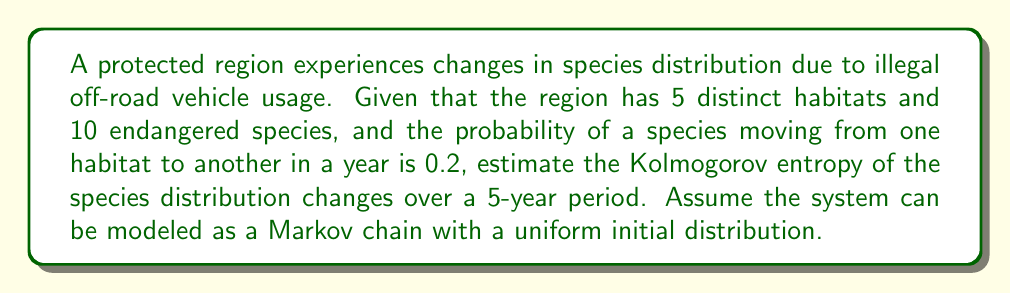Provide a solution to this math problem. To estimate the Kolmogorov entropy of the species distribution changes, we'll follow these steps:

1. Identify the Markov chain transition matrix:
   The probability of staying in the same habitat is $1 - 0.2 = 0.8$, and the probability of moving to any of the other 4 habitats is $0.2 / 4 = 0.05$.

   $$P = \begin{bmatrix}
   0.8 & 0.05 & 0.05 & 0.05 & 0.05 \\
   0.05 & 0.8 & 0.05 & 0.05 & 0.05 \\
   0.05 & 0.05 & 0.8 & 0.05 & 0.05 \\
   0.05 & 0.05 & 0.05 & 0.8 & 0.05 \\
   0.05 & 0.05 & 0.05 & 0.05 & 0.8
   \end{bmatrix}$$

2. Calculate the stationary distribution $\pi$:
   Given the uniform initial distribution, the stationary distribution is also uniform:
   
   $$\pi = (0.2, 0.2, 0.2, 0.2, 0.2)$$

3. Compute the Kolmogorov entropy rate:
   The Kolmogorov entropy rate $h$ is given by:

   $$h = -\sum_{i,j} \pi_i P_{ij} \log P_{ij}$$

   $$h = -5 \cdot (0.2 \cdot 0.8 \log 0.8 + 4 \cdot 0.2 \cdot 0.05 \log 0.05)$$
   $$h \approx 0.5004$$

4. Estimate the Kolmogorov entropy over 5 years:
   The Kolmogorov entropy $H$ over a time period $t$ is approximately:

   $$H \approx h \cdot t$$
   $$H \approx 0.5004 \cdot 5 = 2.502$$

5. Adjust for the number of species:
   Since there are 10 endangered species, we multiply the result by 10:

   $$H_{total} \approx 2.502 \cdot 10 = 25.02$$

This value represents the estimated amount of information (in bits) needed to describe the changes in species distribution over the 5-year period.
Answer: $25.02$ bits 